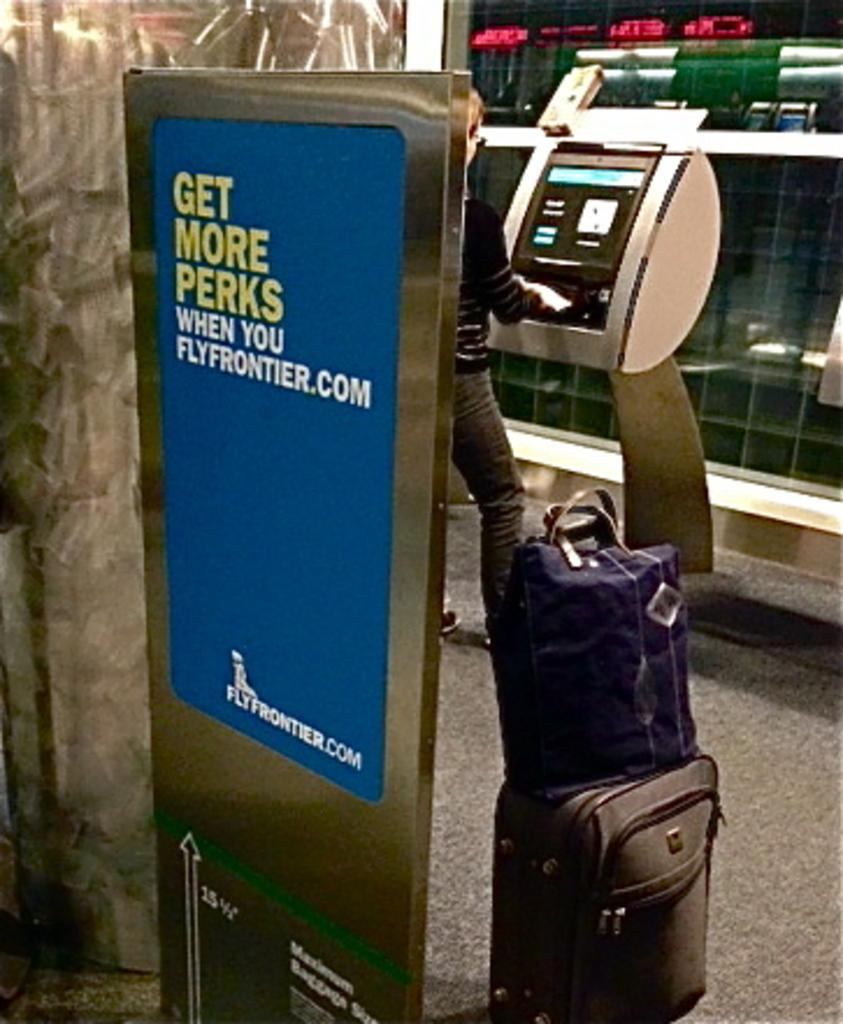What is the person in the image doing? The person is standing at a machine and clicking on buttons. What might the person be working with or producing? The presence of bags beside the person suggests they might be working with or producing bags. What can be seen in the background of the image? There is a wall in the background of the image. What type of mark can be seen on the person's brain in the image? There is no indication of a person's brain or any marks on it in the image. 